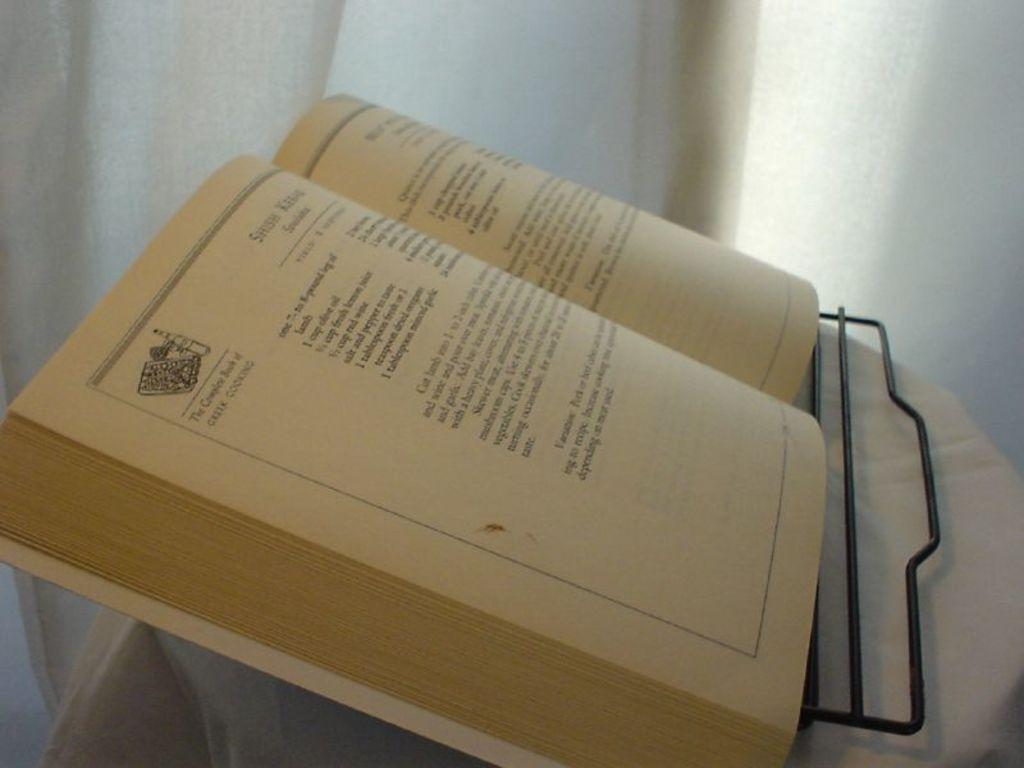<image>
Relay a brief, clear account of the picture shown. The complete book of Greek cooking is printed on the corner of an open book. 